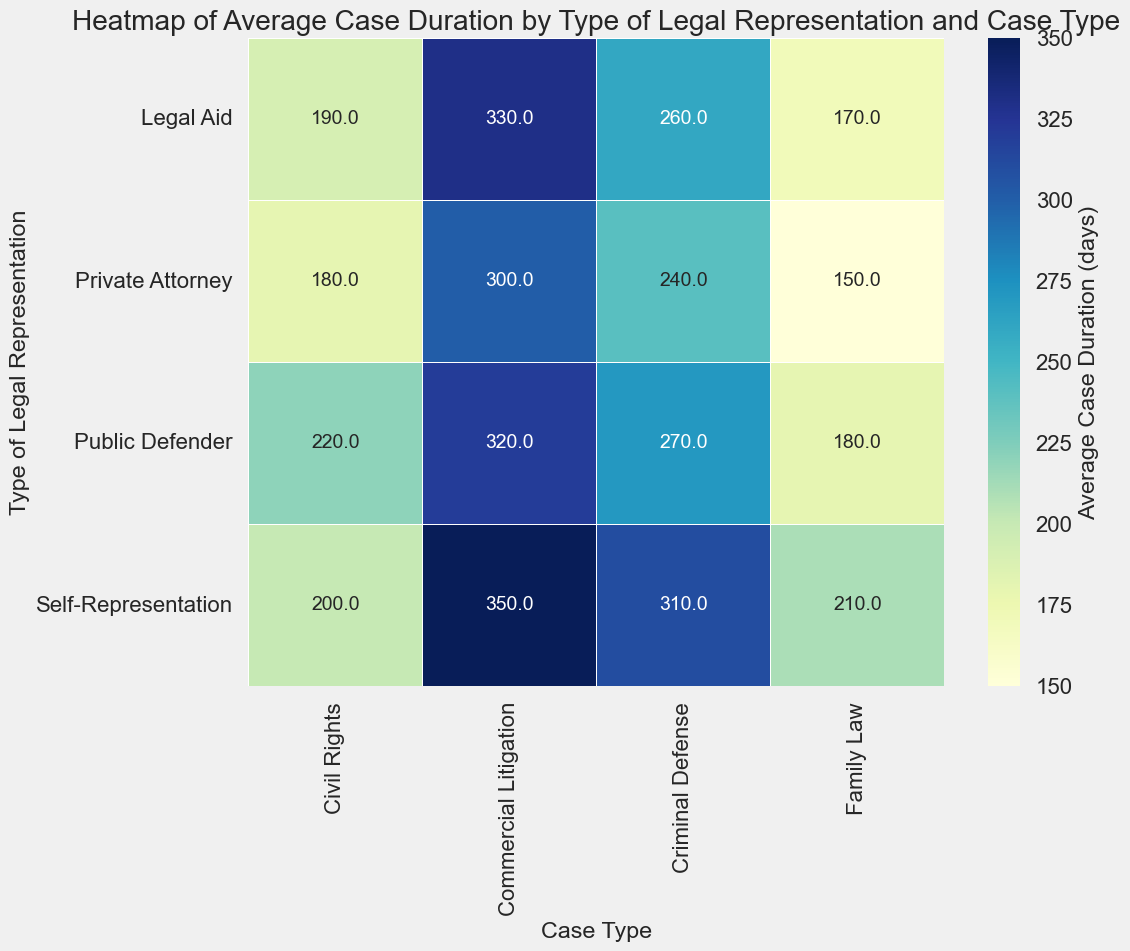What's the average case duration for Civil Rights cases across all types of legal representation? Locate the "Civil Rights" column in the heatmap. Sum the average case durations for each type of legal representation: (180 + 220 + 200 + 190) = 790. Divide by the number of representations (4): 790 / 4 = 197.5 days
Answer: 197.5 days Which type of legal representation has the longest average case duration for Commercial Litigation? Locate the "Commercial Litigation" column in the heatmap. Compare the values for each type of legal representation: Private Attorney (300), Public Defender (320), Self-Representation (350), Legal Aid (330). Self-Representation has the highest value (350)
Answer: Self-Representation Between Legal Aid and Public Defender, which has a higher average case duration for Criminal Defense? Locate the "Criminal Defense" column in the heatmap. Compare the values for "Legal Aid" (260) and "Public Defender" (270). Public Defender has the higher value at 270.
Answer: Public Defender What is the difference in average case duration between Self-Representation and Legal Aid for Family Law cases? Locate the "Family Law" row for "Self-Representation" (210) and "Legal Aid" (170) in the heatmap. Subtract the smaller value from the larger value: 210 - 170 = 40 days
Answer: 40 days What is the relationship in case duration between "Criminal Defense" for Private Attorney and Public Defender? Locate the "Criminal Defense" column in the heatmap. Compare the values for "Private Attorney" (240) and "Public Defender" (270). Public Defender cases last longer on average.
Answer: Public Defender cases last longer Which type of legal representation has the shortest average case duration overall? Locate the smallest value across the entire heatmap. The smallest value is 150 for "Private Attorney" in "Family Law".
Answer: Private Attorney for Family Law Which has a higher average duration in Family Law cases: Public Defender or Private Attorney? Locate the "Family Law" column in the heatmap. Compare "Public Defender" (180) and "Private Attorney" (150). Public Defender has the higher average duration.
Answer: Public Defender 